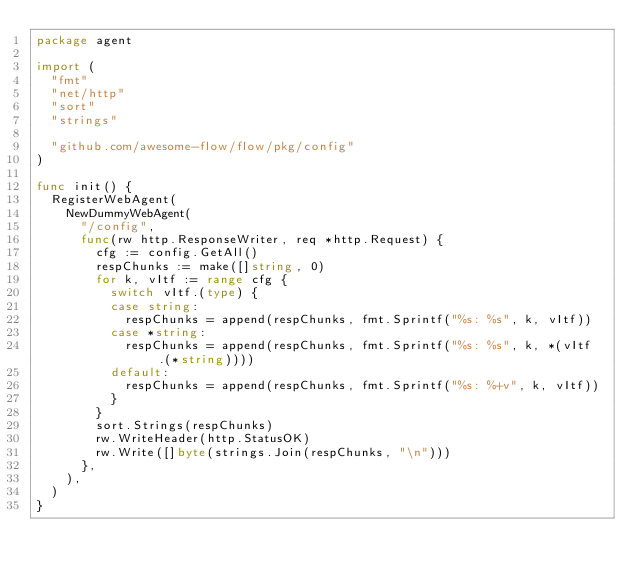<code> <loc_0><loc_0><loc_500><loc_500><_Go_>package agent

import (
	"fmt"
	"net/http"
	"sort"
	"strings"

	"github.com/awesome-flow/flow/pkg/config"
)

func init() {
	RegisterWebAgent(
		NewDummyWebAgent(
			"/config",
			func(rw http.ResponseWriter, req *http.Request) {
				cfg := config.GetAll()
				respChunks := make([]string, 0)
				for k, vItf := range cfg {
					switch vItf.(type) {
					case string:
						respChunks = append(respChunks, fmt.Sprintf("%s: %s", k, vItf))
					case *string:
						respChunks = append(respChunks, fmt.Sprintf("%s: %s", k, *(vItf.(*string))))
					default:
						respChunks = append(respChunks, fmt.Sprintf("%s: %+v", k, vItf))
					}
				}
				sort.Strings(respChunks)
				rw.WriteHeader(http.StatusOK)
				rw.Write([]byte(strings.Join(respChunks, "\n")))
			},
		),
	)
}
</code> 